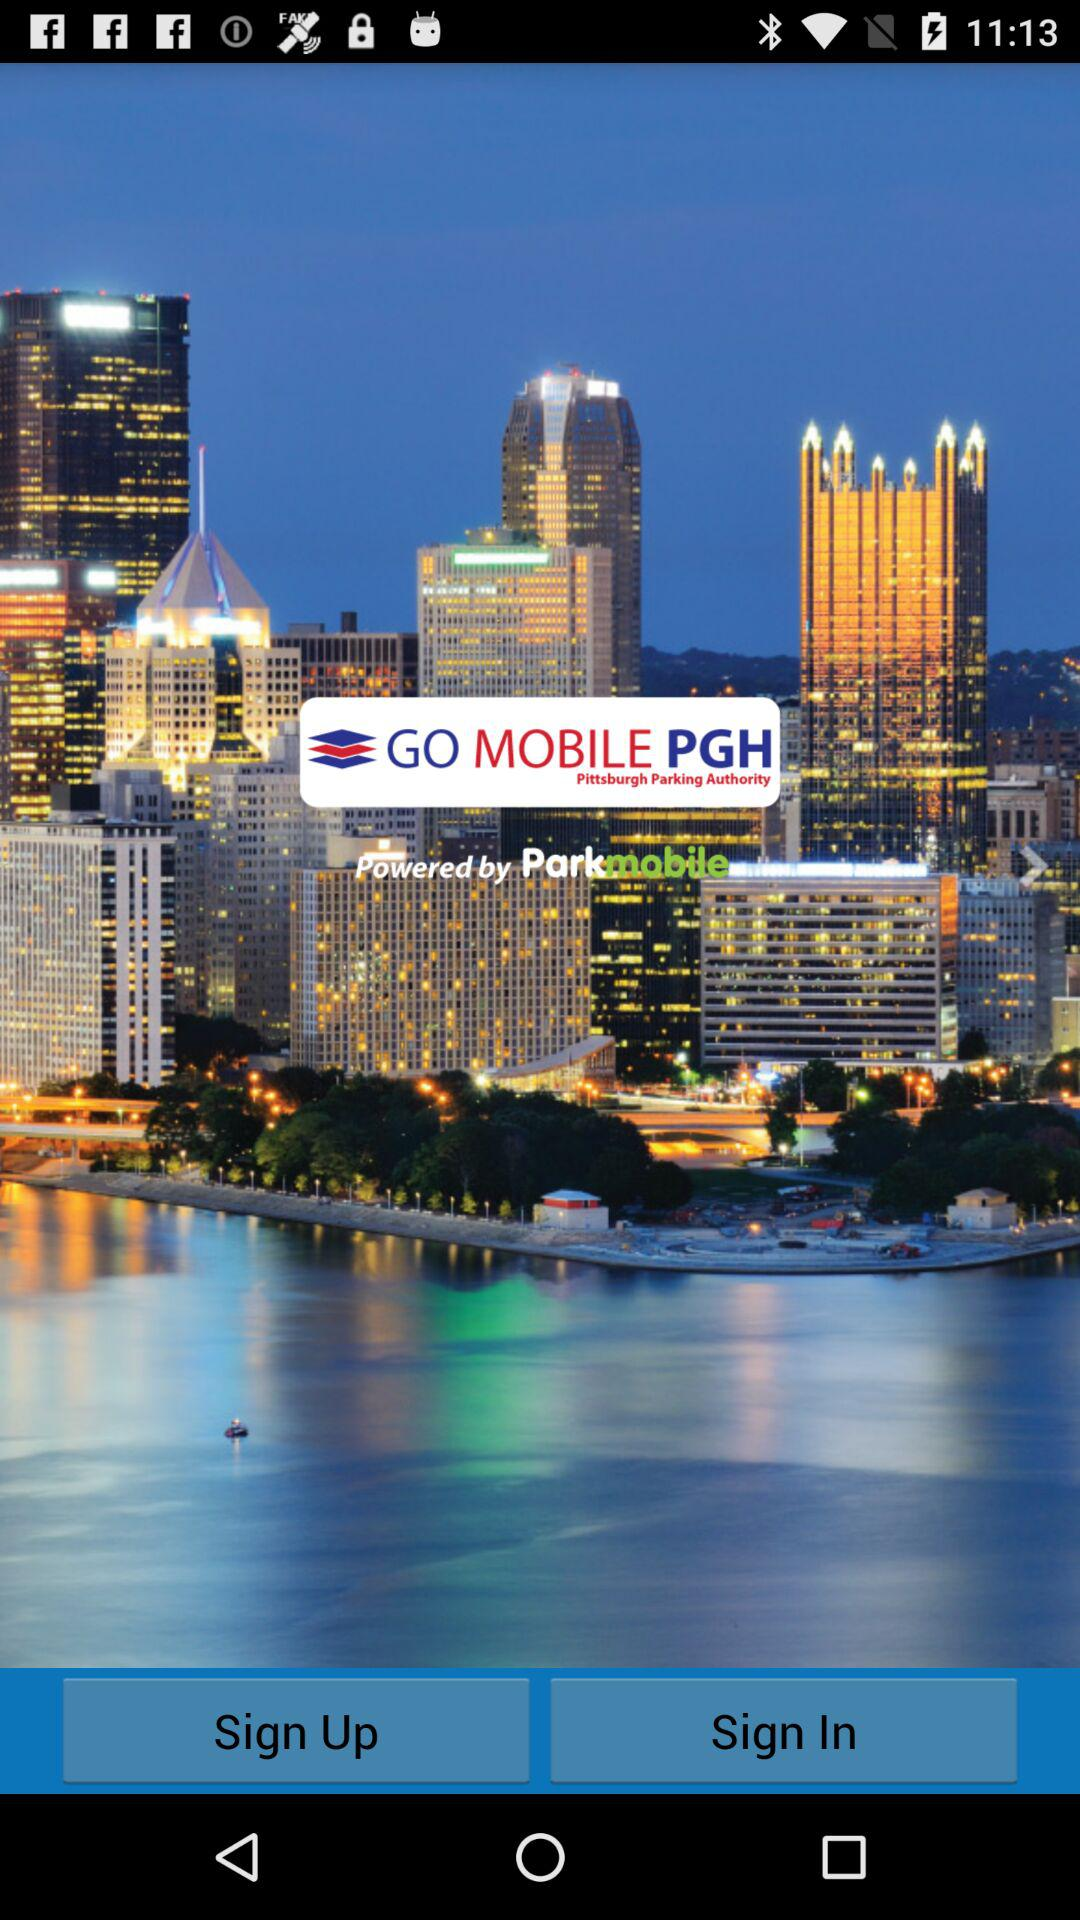What is the application name? The application name is "GO MOBILE PGH". 